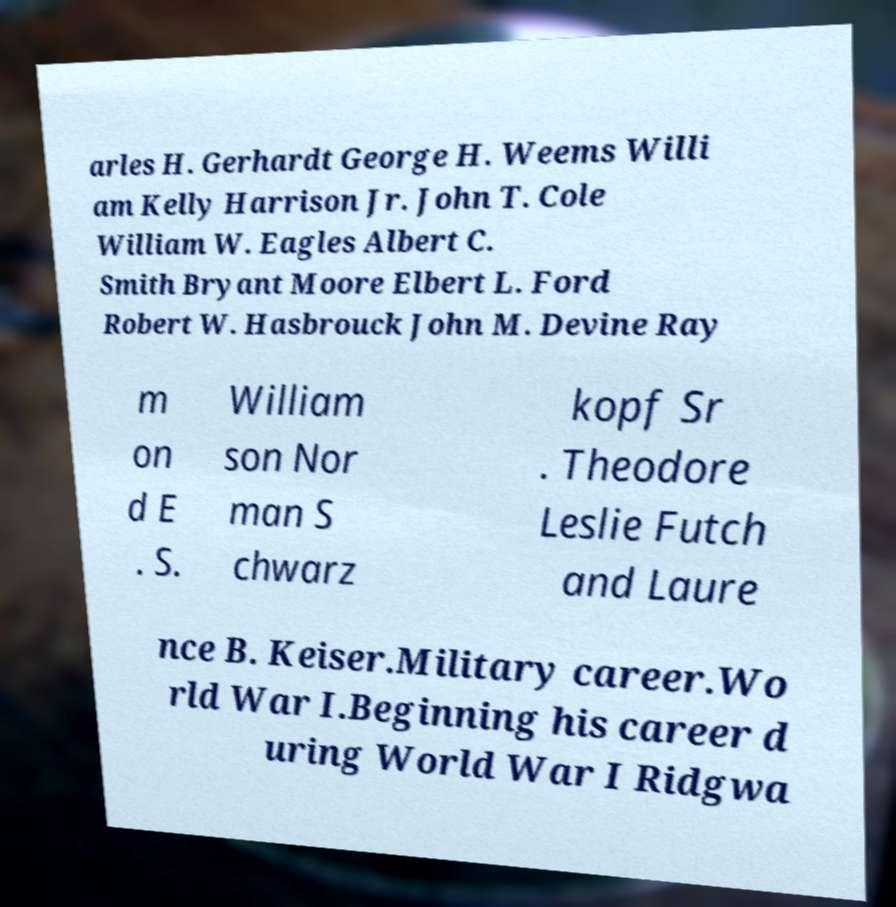Could you assist in decoding the text presented in this image and type it out clearly? arles H. Gerhardt George H. Weems Willi am Kelly Harrison Jr. John T. Cole William W. Eagles Albert C. Smith Bryant Moore Elbert L. Ford Robert W. Hasbrouck John M. Devine Ray m on d E . S. William son Nor man S chwarz kopf Sr . Theodore Leslie Futch and Laure nce B. Keiser.Military career.Wo rld War I.Beginning his career d uring World War I Ridgwa 